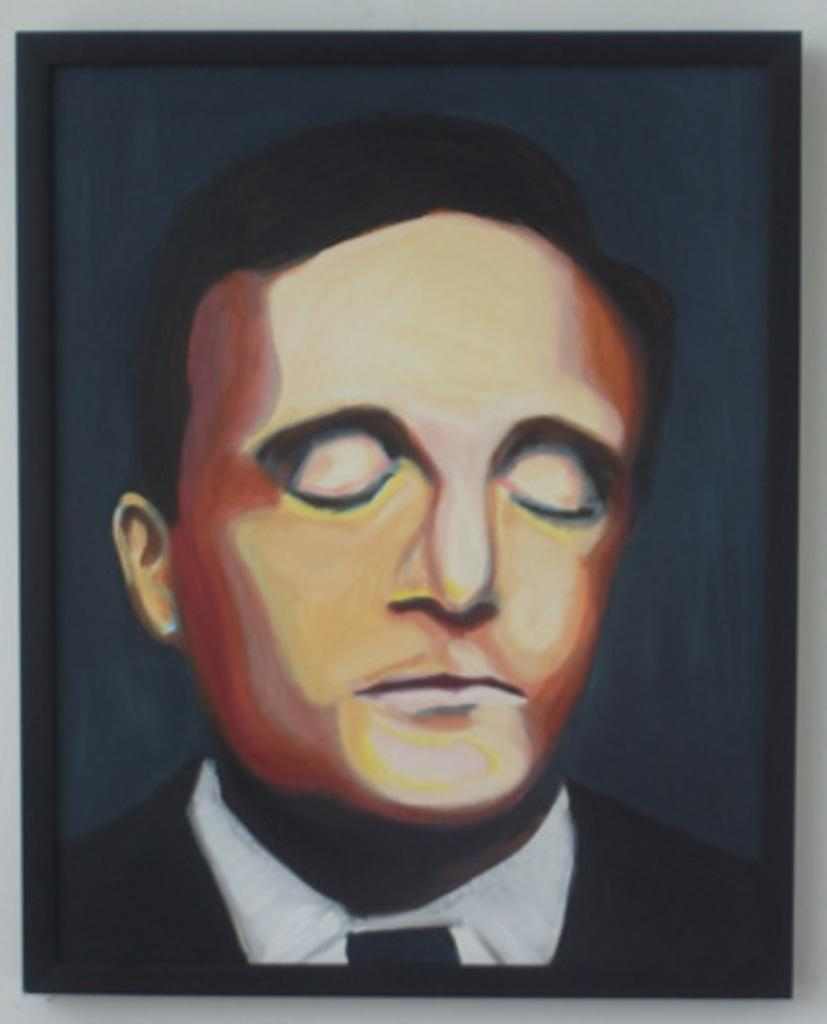What is the main subject of the image? There is a picture of a person in the image. What type of stove is visible in the image? There is no stove present in the image; it only features a picture of a person. How many thumbs does the person in the image have? The number of thumbs the person in the image has cannot be determined from the image alone. 